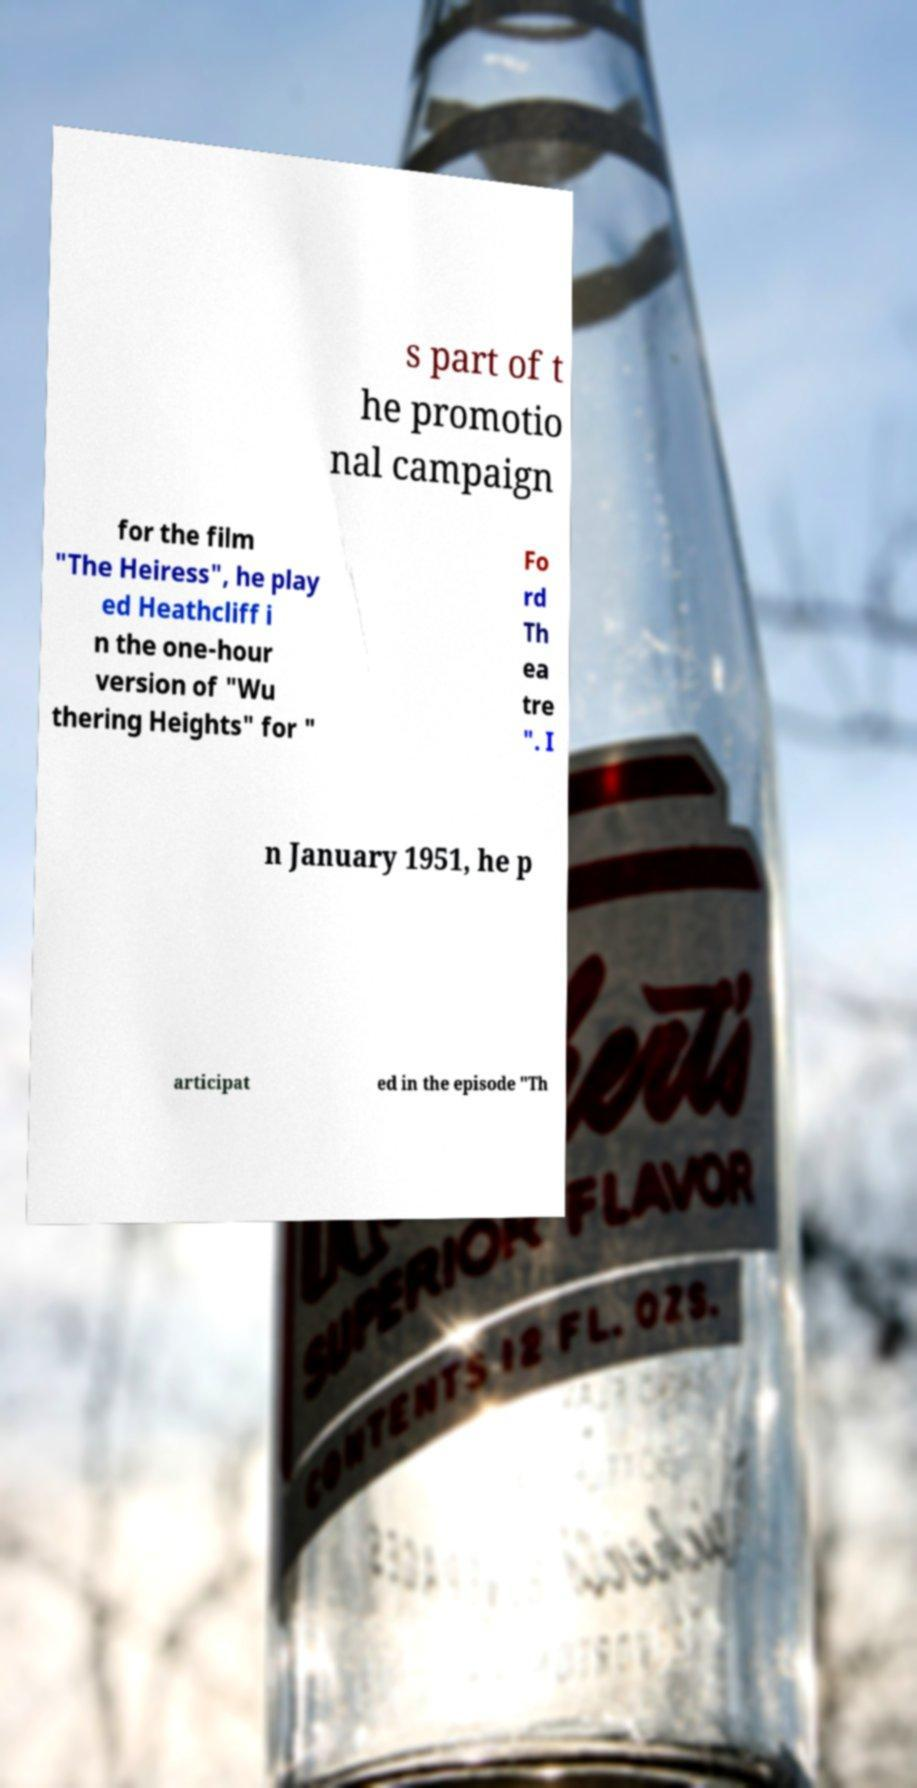For documentation purposes, I need the text within this image transcribed. Could you provide that? s part of t he promotio nal campaign for the film "The Heiress", he play ed Heathcliff i n the one-hour version of "Wu thering Heights" for " Fo rd Th ea tre ". I n January 1951, he p articipat ed in the episode "Th 